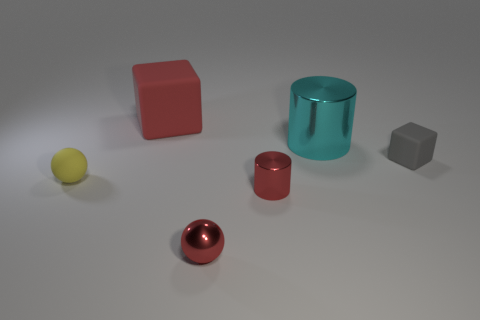Does the big matte cube have the same color as the small metallic ball?
Provide a succinct answer. Yes. The small object that is made of the same material as the yellow sphere is what color?
Give a very brief answer. Gray. Are the cube that is on the left side of the tiny gray rubber thing and the cylinder behind the yellow object made of the same material?
Ensure brevity in your answer.  No. Are there any matte blocks of the same size as the yellow rubber sphere?
Provide a short and direct response. Yes. There is a cylinder that is in front of the block to the right of the small red cylinder; what is its size?
Ensure brevity in your answer.  Small. What number of cubes are the same color as the metal sphere?
Offer a terse response. 1. There is a object that is behind the shiny cylinder behind the red cylinder; what shape is it?
Offer a very short reply. Cube. How many small gray things have the same material as the large cyan thing?
Provide a succinct answer. 0. What is the material of the block in front of the big cyan metal cylinder?
Ensure brevity in your answer.  Rubber. There is a rubber object that is in front of the gray block right of the object that is behind the large cyan cylinder; what shape is it?
Your answer should be very brief. Sphere. 